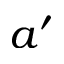Convert formula to latex. <formula><loc_0><loc_0><loc_500><loc_500>a ^ { \prime }</formula> 